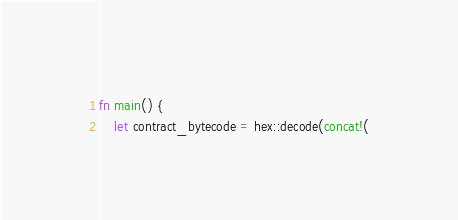<code> <loc_0><loc_0><loc_500><loc_500><_Rust_>fn main() {
    let contract_bytecode = hex::decode(concat!(</code> 